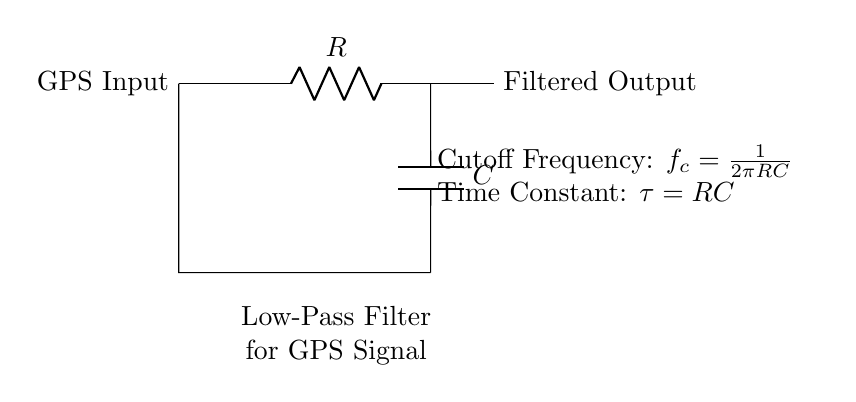What type of filter is this circuit? The circuit is a low-pass filter, as indicated by the label and the arrangement of the resistor and capacitor which allows low-frequency signals to pass while attenuating higher frequencies.
Answer: low-pass filter What is the purpose of the resistor in this circuit? The resistor's purpose is to limit the current and work with the capacitor to establish the cutoff frequency of the filter, determining which frequency components of the GPS signal are allowed through.
Answer: limit current What is the cutoff frequency formula provided in the diagram? The cutoff frequency formula is given as f_c = 1/(2πRC), which describes the frequency at which the output signal's power is halved relative to the input.
Answer: 1/(2πRC) What happens to high-frequency GPS noise in this circuit? High-frequency GPS noise is attenuated, meaning it is reduced in amplitude and does not pass through to the output, effectively smoothing the received signal.
Answer: attenuated What is the time constant in this circuit? The time constant τ is defined as τ = RC, which indicates how quickly the circuit responds to changes in input; it is a critical parameter for determining the filter's performance.
Answer: RC Where does the filtered output connect in the circuit? The filtered output connects directly from the node after the capacitor, which is where the smoothed signal is available for use.
Answer: after the capacitor 